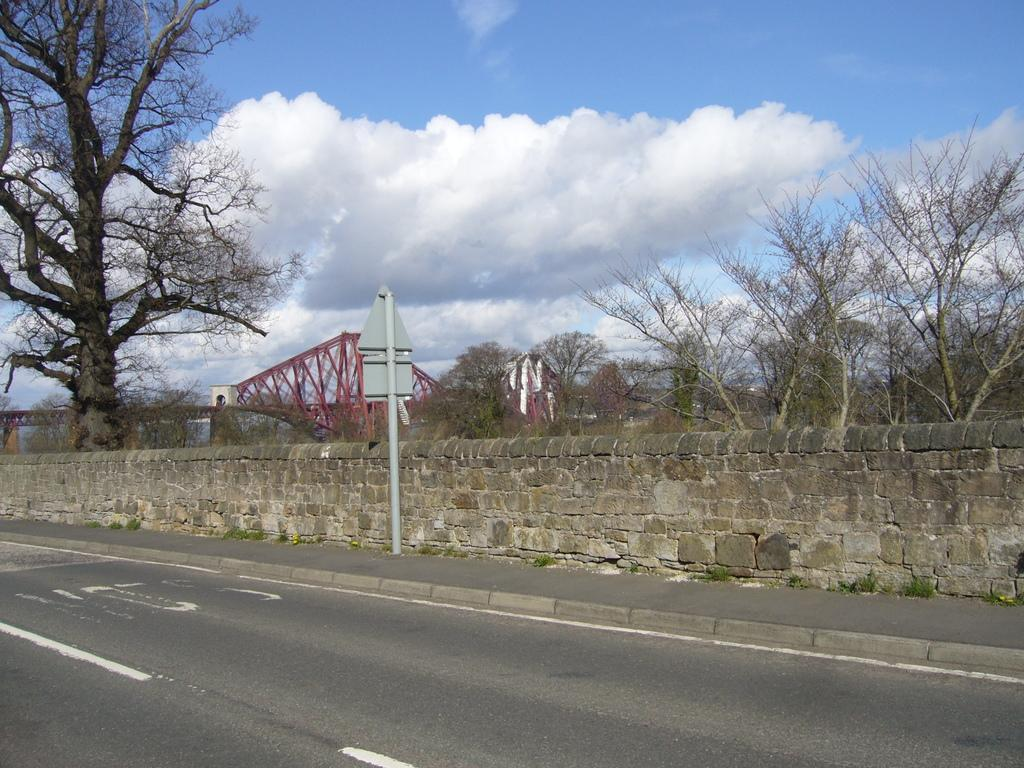What type of structure can be seen in the image? There is a wall in the image. What is located at the bottom of the image? There is a road at the bottom of the image. What can be seen in the background of the image? There are trees in the background of the image. What is visible in the sky at the top of the image? There are clouds visible in the sky at the top of the image. What emotion is the wall displaying in the image? Walls do not display emotions; they are inanimate objects. How many chins can be seen on the trees in the image? There are no chins present on the trees in the image, as trees do not have chins. 